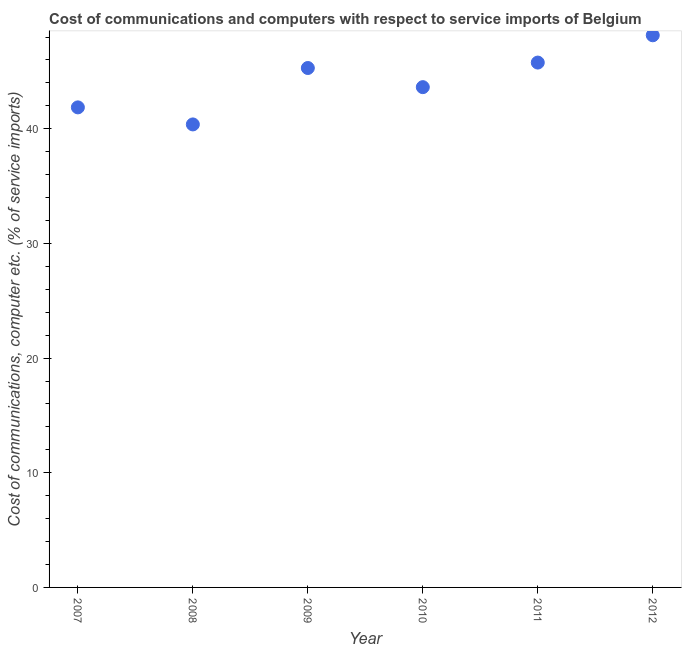What is the cost of communications and computer in 2012?
Provide a short and direct response. 48.16. Across all years, what is the maximum cost of communications and computer?
Your answer should be very brief. 48.16. Across all years, what is the minimum cost of communications and computer?
Your answer should be compact. 40.38. What is the sum of the cost of communications and computer?
Offer a terse response. 265.11. What is the difference between the cost of communications and computer in 2007 and 2009?
Offer a terse response. -3.43. What is the average cost of communications and computer per year?
Your response must be concise. 44.19. What is the median cost of communications and computer?
Your answer should be very brief. 44.47. In how many years, is the cost of communications and computer greater than 2 %?
Your answer should be compact. 6. What is the ratio of the cost of communications and computer in 2008 to that in 2011?
Offer a terse response. 0.88. Is the cost of communications and computer in 2010 less than that in 2012?
Ensure brevity in your answer.  Yes. Is the difference between the cost of communications and computer in 2008 and 2009 greater than the difference between any two years?
Keep it short and to the point. No. What is the difference between the highest and the second highest cost of communications and computer?
Your answer should be very brief. 2.38. Is the sum of the cost of communications and computer in 2010 and 2011 greater than the maximum cost of communications and computer across all years?
Your answer should be compact. Yes. What is the difference between the highest and the lowest cost of communications and computer?
Your response must be concise. 7.77. In how many years, is the cost of communications and computer greater than the average cost of communications and computer taken over all years?
Make the answer very short. 3. Does the cost of communications and computer monotonically increase over the years?
Keep it short and to the point. No. How many years are there in the graph?
Make the answer very short. 6. What is the difference between two consecutive major ticks on the Y-axis?
Your answer should be compact. 10. Are the values on the major ticks of Y-axis written in scientific E-notation?
Your response must be concise. No. What is the title of the graph?
Your response must be concise. Cost of communications and computers with respect to service imports of Belgium. What is the label or title of the X-axis?
Offer a terse response. Year. What is the label or title of the Y-axis?
Ensure brevity in your answer.  Cost of communications, computer etc. (% of service imports). What is the Cost of communications, computer etc. (% of service imports) in 2007?
Provide a short and direct response. 41.87. What is the Cost of communications, computer etc. (% of service imports) in 2008?
Provide a succinct answer. 40.38. What is the Cost of communications, computer etc. (% of service imports) in 2009?
Give a very brief answer. 45.3. What is the Cost of communications, computer etc. (% of service imports) in 2010?
Keep it short and to the point. 43.63. What is the Cost of communications, computer etc. (% of service imports) in 2011?
Provide a short and direct response. 45.78. What is the Cost of communications, computer etc. (% of service imports) in 2012?
Give a very brief answer. 48.16. What is the difference between the Cost of communications, computer etc. (% of service imports) in 2007 and 2008?
Your answer should be very brief. 1.49. What is the difference between the Cost of communications, computer etc. (% of service imports) in 2007 and 2009?
Keep it short and to the point. -3.43. What is the difference between the Cost of communications, computer etc. (% of service imports) in 2007 and 2010?
Ensure brevity in your answer.  -1.76. What is the difference between the Cost of communications, computer etc. (% of service imports) in 2007 and 2011?
Offer a very short reply. -3.91. What is the difference between the Cost of communications, computer etc. (% of service imports) in 2007 and 2012?
Give a very brief answer. -6.29. What is the difference between the Cost of communications, computer etc. (% of service imports) in 2008 and 2009?
Provide a succinct answer. -4.92. What is the difference between the Cost of communications, computer etc. (% of service imports) in 2008 and 2010?
Your response must be concise. -3.25. What is the difference between the Cost of communications, computer etc. (% of service imports) in 2008 and 2011?
Your response must be concise. -5.39. What is the difference between the Cost of communications, computer etc. (% of service imports) in 2008 and 2012?
Make the answer very short. -7.77. What is the difference between the Cost of communications, computer etc. (% of service imports) in 2009 and 2010?
Your answer should be compact. 1.67. What is the difference between the Cost of communications, computer etc. (% of service imports) in 2009 and 2011?
Offer a very short reply. -0.47. What is the difference between the Cost of communications, computer etc. (% of service imports) in 2009 and 2012?
Make the answer very short. -2.85. What is the difference between the Cost of communications, computer etc. (% of service imports) in 2010 and 2011?
Give a very brief answer. -2.14. What is the difference between the Cost of communications, computer etc. (% of service imports) in 2010 and 2012?
Your answer should be compact. -4.52. What is the difference between the Cost of communications, computer etc. (% of service imports) in 2011 and 2012?
Ensure brevity in your answer.  -2.38. What is the ratio of the Cost of communications, computer etc. (% of service imports) in 2007 to that in 2009?
Your response must be concise. 0.92. What is the ratio of the Cost of communications, computer etc. (% of service imports) in 2007 to that in 2010?
Keep it short and to the point. 0.96. What is the ratio of the Cost of communications, computer etc. (% of service imports) in 2007 to that in 2011?
Offer a very short reply. 0.92. What is the ratio of the Cost of communications, computer etc. (% of service imports) in 2007 to that in 2012?
Your answer should be compact. 0.87. What is the ratio of the Cost of communications, computer etc. (% of service imports) in 2008 to that in 2009?
Give a very brief answer. 0.89. What is the ratio of the Cost of communications, computer etc. (% of service imports) in 2008 to that in 2010?
Your answer should be compact. 0.93. What is the ratio of the Cost of communications, computer etc. (% of service imports) in 2008 to that in 2011?
Provide a succinct answer. 0.88. What is the ratio of the Cost of communications, computer etc. (% of service imports) in 2008 to that in 2012?
Your answer should be very brief. 0.84. What is the ratio of the Cost of communications, computer etc. (% of service imports) in 2009 to that in 2010?
Provide a succinct answer. 1.04. What is the ratio of the Cost of communications, computer etc. (% of service imports) in 2009 to that in 2012?
Keep it short and to the point. 0.94. What is the ratio of the Cost of communications, computer etc. (% of service imports) in 2010 to that in 2011?
Keep it short and to the point. 0.95. What is the ratio of the Cost of communications, computer etc. (% of service imports) in 2010 to that in 2012?
Provide a short and direct response. 0.91. What is the ratio of the Cost of communications, computer etc. (% of service imports) in 2011 to that in 2012?
Your answer should be compact. 0.95. 